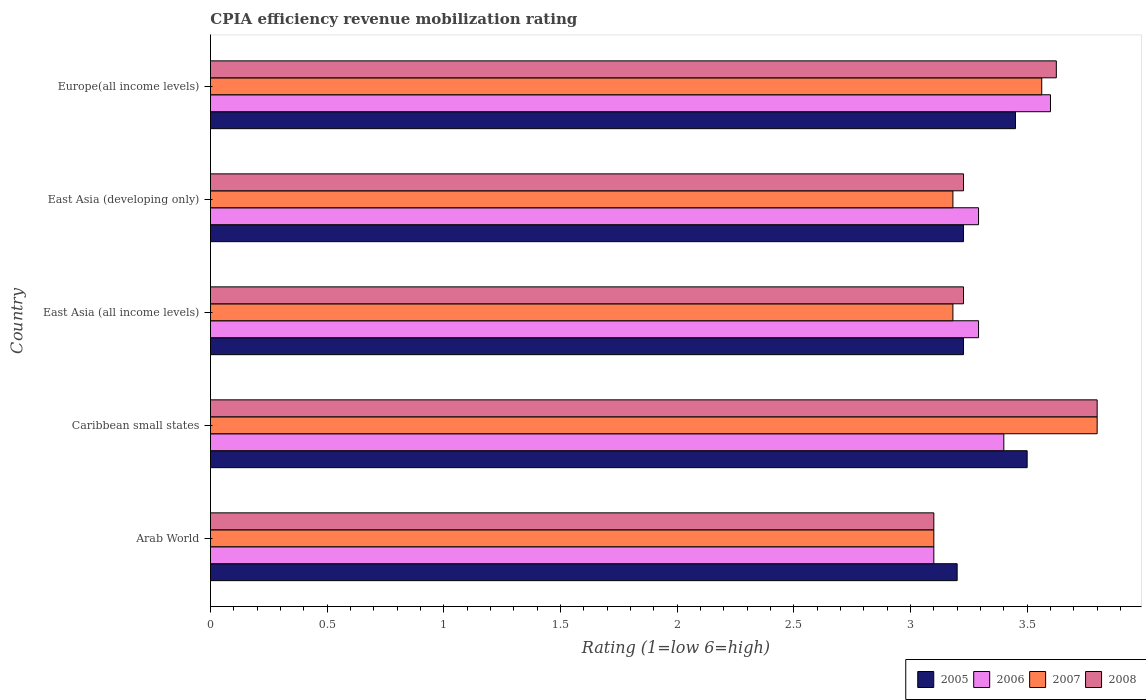How many different coloured bars are there?
Provide a succinct answer. 4. Are the number of bars per tick equal to the number of legend labels?
Offer a very short reply. Yes. Are the number of bars on each tick of the Y-axis equal?
Offer a terse response. Yes. How many bars are there on the 5th tick from the top?
Give a very brief answer. 4. How many bars are there on the 1st tick from the bottom?
Make the answer very short. 4. What is the label of the 5th group of bars from the top?
Provide a short and direct response. Arab World. In how many cases, is the number of bars for a given country not equal to the number of legend labels?
Your answer should be compact. 0. What is the CPIA rating in 2006 in East Asia (all income levels)?
Provide a succinct answer. 3.29. Across all countries, what is the maximum CPIA rating in 2008?
Your answer should be compact. 3.8. Across all countries, what is the minimum CPIA rating in 2008?
Provide a short and direct response. 3.1. In which country was the CPIA rating in 2008 maximum?
Offer a terse response. Caribbean small states. In which country was the CPIA rating in 2008 minimum?
Make the answer very short. Arab World. What is the total CPIA rating in 2007 in the graph?
Make the answer very short. 16.83. What is the difference between the CPIA rating in 2007 in Caribbean small states and the CPIA rating in 2006 in Europe(all income levels)?
Provide a succinct answer. 0.2. What is the average CPIA rating in 2007 per country?
Make the answer very short. 3.37. What is the difference between the CPIA rating in 2006 and CPIA rating in 2005 in Caribbean small states?
Your response must be concise. -0.1. What is the ratio of the CPIA rating in 2005 in Arab World to that in East Asia (all income levels)?
Provide a succinct answer. 0.99. Is the CPIA rating in 2005 in Arab World less than that in East Asia (all income levels)?
Ensure brevity in your answer.  Yes. What is the difference between the highest and the second highest CPIA rating in 2006?
Make the answer very short. 0.2. What is the difference between the highest and the lowest CPIA rating in 2005?
Your answer should be compact. 0.3. In how many countries, is the CPIA rating in 2005 greater than the average CPIA rating in 2005 taken over all countries?
Your answer should be compact. 2. Is the sum of the CPIA rating in 2008 in Caribbean small states and East Asia (developing only) greater than the maximum CPIA rating in 2005 across all countries?
Make the answer very short. Yes. Is it the case that in every country, the sum of the CPIA rating in 2007 and CPIA rating in 2006 is greater than the sum of CPIA rating in 2008 and CPIA rating in 2005?
Ensure brevity in your answer.  No. Is it the case that in every country, the sum of the CPIA rating in 2005 and CPIA rating in 2006 is greater than the CPIA rating in 2007?
Provide a short and direct response. Yes. How many countries are there in the graph?
Your response must be concise. 5. What is the difference between two consecutive major ticks on the X-axis?
Give a very brief answer. 0.5. Are the values on the major ticks of X-axis written in scientific E-notation?
Offer a very short reply. No. Does the graph contain any zero values?
Your answer should be compact. No. Where does the legend appear in the graph?
Your response must be concise. Bottom right. How many legend labels are there?
Keep it short and to the point. 4. How are the legend labels stacked?
Your response must be concise. Horizontal. What is the title of the graph?
Keep it short and to the point. CPIA efficiency revenue mobilization rating. Does "2014" appear as one of the legend labels in the graph?
Your response must be concise. No. What is the label or title of the X-axis?
Your response must be concise. Rating (1=low 6=high). What is the Rating (1=low 6=high) in 2006 in Arab World?
Make the answer very short. 3.1. What is the Rating (1=low 6=high) of 2007 in Arab World?
Offer a terse response. 3.1. What is the Rating (1=low 6=high) of 2008 in Arab World?
Give a very brief answer. 3.1. What is the Rating (1=low 6=high) in 2005 in Caribbean small states?
Provide a short and direct response. 3.5. What is the Rating (1=low 6=high) in 2006 in Caribbean small states?
Give a very brief answer. 3.4. What is the Rating (1=low 6=high) of 2007 in Caribbean small states?
Your response must be concise. 3.8. What is the Rating (1=low 6=high) in 2005 in East Asia (all income levels)?
Make the answer very short. 3.23. What is the Rating (1=low 6=high) in 2006 in East Asia (all income levels)?
Ensure brevity in your answer.  3.29. What is the Rating (1=low 6=high) of 2007 in East Asia (all income levels)?
Your response must be concise. 3.18. What is the Rating (1=low 6=high) of 2008 in East Asia (all income levels)?
Keep it short and to the point. 3.23. What is the Rating (1=low 6=high) of 2005 in East Asia (developing only)?
Provide a short and direct response. 3.23. What is the Rating (1=low 6=high) of 2006 in East Asia (developing only)?
Your answer should be very brief. 3.29. What is the Rating (1=low 6=high) in 2007 in East Asia (developing only)?
Make the answer very short. 3.18. What is the Rating (1=low 6=high) of 2008 in East Asia (developing only)?
Provide a succinct answer. 3.23. What is the Rating (1=low 6=high) of 2005 in Europe(all income levels)?
Offer a terse response. 3.45. What is the Rating (1=low 6=high) in 2006 in Europe(all income levels)?
Ensure brevity in your answer.  3.6. What is the Rating (1=low 6=high) of 2007 in Europe(all income levels)?
Your answer should be very brief. 3.56. What is the Rating (1=low 6=high) in 2008 in Europe(all income levels)?
Provide a succinct answer. 3.62. Across all countries, what is the maximum Rating (1=low 6=high) of 2005?
Give a very brief answer. 3.5. Across all countries, what is the maximum Rating (1=low 6=high) of 2006?
Keep it short and to the point. 3.6. Across all countries, what is the maximum Rating (1=low 6=high) of 2008?
Provide a succinct answer. 3.8. Across all countries, what is the minimum Rating (1=low 6=high) in 2006?
Your answer should be very brief. 3.1. What is the total Rating (1=low 6=high) in 2005 in the graph?
Your answer should be very brief. 16.6. What is the total Rating (1=low 6=high) of 2006 in the graph?
Your answer should be very brief. 16.68. What is the total Rating (1=low 6=high) in 2007 in the graph?
Your answer should be compact. 16.83. What is the total Rating (1=low 6=high) of 2008 in the graph?
Offer a terse response. 16.98. What is the difference between the Rating (1=low 6=high) of 2005 in Arab World and that in Caribbean small states?
Offer a very short reply. -0.3. What is the difference between the Rating (1=low 6=high) of 2006 in Arab World and that in Caribbean small states?
Provide a succinct answer. -0.3. What is the difference between the Rating (1=low 6=high) of 2007 in Arab World and that in Caribbean small states?
Keep it short and to the point. -0.7. What is the difference between the Rating (1=low 6=high) of 2008 in Arab World and that in Caribbean small states?
Give a very brief answer. -0.7. What is the difference between the Rating (1=low 6=high) in 2005 in Arab World and that in East Asia (all income levels)?
Keep it short and to the point. -0.03. What is the difference between the Rating (1=low 6=high) of 2006 in Arab World and that in East Asia (all income levels)?
Offer a very short reply. -0.19. What is the difference between the Rating (1=low 6=high) in 2007 in Arab World and that in East Asia (all income levels)?
Keep it short and to the point. -0.08. What is the difference between the Rating (1=low 6=high) of 2008 in Arab World and that in East Asia (all income levels)?
Keep it short and to the point. -0.13. What is the difference between the Rating (1=low 6=high) in 2005 in Arab World and that in East Asia (developing only)?
Provide a short and direct response. -0.03. What is the difference between the Rating (1=low 6=high) of 2006 in Arab World and that in East Asia (developing only)?
Keep it short and to the point. -0.19. What is the difference between the Rating (1=low 6=high) in 2007 in Arab World and that in East Asia (developing only)?
Provide a short and direct response. -0.08. What is the difference between the Rating (1=low 6=high) in 2008 in Arab World and that in East Asia (developing only)?
Keep it short and to the point. -0.13. What is the difference between the Rating (1=low 6=high) of 2006 in Arab World and that in Europe(all income levels)?
Keep it short and to the point. -0.5. What is the difference between the Rating (1=low 6=high) of 2007 in Arab World and that in Europe(all income levels)?
Your answer should be very brief. -0.46. What is the difference between the Rating (1=low 6=high) of 2008 in Arab World and that in Europe(all income levels)?
Your response must be concise. -0.53. What is the difference between the Rating (1=low 6=high) of 2005 in Caribbean small states and that in East Asia (all income levels)?
Keep it short and to the point. 0.27. What is the difference between the Rating (1=low 6=high) in 2006 in Caribbean small states and that in East Asia (all income levels)?
Give a very brief answer. 0.11. What is the difference between the Rating (1=low 6=high) in 2007 in Caribbean small states and that in East Asia (all income levels)?
Your answer should be very brief. 0.62. What is the difference between the Rating (1=low 6=high) in 2008 in Caribbean small states and that in East Asia (all income levels)?
Offer a very short reply. 0.57. What is the difference between the Rating (1=low 6=high) of 2005 in Caribbean small states and that in East Asia (developing only)?
Keep it short and to the point. 0.27. What is the difference between the Rating (1=low 6=high) in 2006 in Caribbean small states and that in East Asia (developing only)?
Give a very brief answer. 0.11. What is the difference between the Rating (1=low 6=high) in 2007 in Caribbean small states and that in East Asia (developing only)?
Your answer should be compact. 0.62. What is the difference between the Rating (1=low 6=high) in 2008 in Caribbean small states and that in East Asia (developing only)?
Offer a very short reply. 0.57. What is the difference between the Rating (1=low 6=high) in 2005 in Caribbean small states and that in Europe(all income levels)?
Offer a very short reply. 0.05. What is the difference between the Rating (1=low 6=high) of 2007 in Caribbean small states and that in Europe(all income levels)?
Keep it short and to the point. 0.24. What is the difference between the Rating (1=low 6=high) in 2008 in Caribbean small states and that in Europe(all income levels)?
Offer a terse response. 0.17. What is the difference between the Rating (1=low 6=high) in 2005 in East Asia (all income levels) and that in East Asia (developing only)?
Provide a short and direct response. 0. What is the difference between the Rating (1=low 6=high) of 2008 in East Asia (all income levels) and that in East Asia (developing only)?
Your answer should be very brief. 0. What is the difference between the Rating (1=low 6=high) of 2005 in East Asia (all income levels) and that in Europe(all income levels)?
Give a very brief answer. -0.22. What is the difference between the Rating (1=low 6=high) of 2006 in East Asia (all income levels) and that in Europe(all income levels)?
Keep it short and to the point. -0.31. What is the difference between the Rating (1=low 6=high) of 2007 in East Asia (all income levels) and that in Europe(all income levels)?
Give a very brief answer. -0.38. What is the difference between the Rating (1=low 6=high) of 2008 in East Asia (all income levels) and that in Europe(all income levels)?
Make the answer very short. -0.4. What is the difference between the Rating (1=low 6=high) in 2005 in East Asia (developing only) and that in Europe(all income levels)?
Ensure brevity in your answer.  -0.22. What is the difference between the Rating (1=low 6=high) in 2006 in East Asia (developing only) and that in Europe(all income levels)?
Make the answer very short. -0.31. What is the difference between the Rating (1=low 6=high) of 2007 in East Asia (developing only) and that in Europe(all income levels)?
Give a very brief answer. -0.38. What is the difference between the Rating (1=low 6=high) in 2008 in East Asia (developing only) and that in Europe(all income levels)?
Keep it short and to the point. -0.4. What is the difference between the Rating (1=low 6=high) of 2005 in Arab World and the Rating (1=low 6=high) of 2006 in Caribbean small states?
Ensure brevity in your answer.  -0.2. What is the difference between the Rating (1=low 6=high) in 2005 in Arab World and the Rating (1=low 6=high) in 2007 in Caribbean small states?
Make the answer very short. -0.6. What is the difference between the Rating (1=low 6=high) in 2006 in Arab World and the Rating (1=low 6=high) in 2007 in Caribbean small states?
Offer a terse response. -0.7. What is the difference between the Rating (1=low 6=high) in 2007 in Arab World and the Rating (1=low 6=high) in 2008 in Caribbean small states?
Make the answer very short. -0.7. What is the difference between the Rating (1=low 6=high) in 2005 in Arab World and the Rating (1=low 6=high) in 2006 in East Asia (all income levels)?
Your answer should be very brief. -0.09. What is the difference between the Rating (1=low 6=high) of 2005 in Arab World and the Rating (1=low 6=high) of 2007 in East Asia (all income levels)?
Ensure brevity in your answer.  0.02. What is the difference between the Rating (1=low 6=high) of 2005 in Arab World and the Rating (1=low 6=high) of 2008 in East Asia (all income levels)?
Provide a succinct answer. -0.03. What is the difference between the Rating (1=low 6=high) in 2006 in Arab World and the Rating (1=low 6=high) in 2007 in East Asia (all income levels)?
Ensure brevity in your answer.  -0.08. What is the difference between the Rating (1=low 6=high) in 2006 in Arab World and the Rating (1=low 6=high) in 2008 in East Asia (all income levels)?
Keep it short and to the point. -0.13. What is the difference between the Rating (1=low 6=high) in 2007 in Arab World and the Rating (1=low 6=high) in 2008 in East Asia (all income levels)?
Offer a terse response. -0.13. What is the difference between the Rating (1=low 6=high) of 2005 in Arab World and the Rating (1=low 6=high) of 2006 in East Asia (developing only)?
Provide a short and direct response. -0.09. What is the difference between the Rating (1=low 6=high) of 2005 in Arab World and the Rating (1=low 6=high) of 2007 in East Asia (developing only)?
Keep it short and to the point. 0.02. What is the difference between the Rating (1=low 6=high) in 2005 in Arab World and the Rating (1=low 6=high) in 2008 in East Asia (developing only)?
Offer a terse response. -0.03. What is the difference between the Rating (1=low 6=high) in 2006 in Arab World and the Rating (1=low 6=high) in 2007 in East Asia (developing only)?
Provide a succinct answer. -0.08. What is the difference between the Rating (1=low 6=high) in 2006 in Arab World and the Rating (1=low 6=high) in 2008 in East Asia (developing only)?
Offer a very short reply. -0.13. What is the difference between the Rating (1=low 6=high) in 2007 in Arab World and the Rating (1=low 6=high) in 2008 in East Asia (developing only)?
Offer a very short reply. -0.13. What is the difference between the Rating (1=low 6=high) in 2005 in Arab World and the Rating (1=low 6=high) in 2006 in Europe(all income levels)?
Keep it short and to the point. -0.4. What is the difference between the Rating (1=low 6=high) of 2005 in Arab World and the Rating (1=low 6=high) of 2007 in Europe(all income levels)?
Provide a short and direct response. -0.36. What is the difference between the Rating (1=low 6=high) in 2005 in Arab World and the Rating (1=low 6=high) in 2008 in Europe(all income levels)?
Give a very brief answer. -0.42. What is the difference between the Rating (1=low 6=high) of 2006 in Arab World and the Rating (1=low 6=high) of 2007 in Europe(all income levels)?
Offer a very short reply. -0.46. What is the difference between the Rating (1=low 6=high) in 2006 in Arab World and the Rating (1=low 6=high) in 2008 in Europe(all income levels)?
Your answer should be very brief. -0.53. What is the difference between the Rating (1=low 6=high) in 2007 in Arab World and the Rating (1=low 6=high) in 2008 in Europe(all income levels)?
Your answer should be very brief. -0.53. What is the difference between the Rating (1=low 6=high) in 2005 in Caribbean small states and the Rating (1=low 6=high) in 2006 in East Asia (all income levels)?
Provide a succinct answer. 0.21. What is the difference between the Rating (1=low 6=high) of 2005 in Caribbean small states and the Rating (1=low 6=high) of 2007 in East Asia (all income levels)?
Ensure brevity in your answer.  0.32. What is the difference between the Rating (1=low 6=high) in 2005 in Caribbean small states and the Rating (1=low 6=high) in 2008 in East Asia (all income levels)?
Your response must be concise. 0.27. What is the difference between the Rating (1=low 6=high) of 2006 in Caribbean small states and the Rating (1=low 6=high) of 2007 in East Asia (all income levels)?
Keep it short and to the point. 0.22. What is the difference between the Rating (1=low 6=high) in 2006 in Caribbean small states and the Rating (1=low 6=high) in 2008 in East Asia (all income levels)?
Give a very brief answer. 0.17. What is the difference between the Rating (1=low 6=high) in 2007 in Caribbean small states and the Rating (1=low 6=high) in 2008 in East Asia (all income levels)?
Ensure brevity in your answer.  0.57. What is the difference between the Rating (1=low 6=high) of 2005 in Caribbean small states and the Rating (1=low 6=high) of 2006 in East Asia (developing only)?
Offer a terse response. 0.21. What is the difference between the Rating (1=low 6=high) of 2005 in Caribbean small states and the Rating (1=low 6=high) of 2007 in East Asia (developing only)?
Offer a very short reply. 0.32. What is the difference between the Rating (1=low 6=high) of 2005 in Caribbean small states and the Rating (1=low 6=high) of 2008 in East Asia (developing only)?
Offer a terse response. 0.27. What is the difference between the Rating (1=low 6=high) of 2006 in Caribbean small states and the Rating (1=low 6=high) of 2007 in East Asia (developing only)?
Your answer should be compact. 0.22. What is the difference between the Rating (1=low 6=high) of 2006 in Caribbean small states and the Rating (1=low 6=high) of 2008 in East Asia (developing only)?
Make the answer very short. 0.17. What is the difference between the Rating (1=low 6=high) in 2007 in Caribbean small states and the Rating (1=low 6=high) in 2008 in East Asia (developing only)?
Make the answer very short. 0.57. What is the difference between the Rating (1=low 6=high) of 2005 in Caribbean small states and the Rating (1=low 6=high) of 2007 in Europe(all income levels)?
Provide a succinct answer. -0.06. What is the difference between the Rating (1=low 6=high) in 2005 in Caribbean small states and the Rating (1=low 6=high) in 2008 in Europe(all income levels)?
Ensure brevity in your answer.  -0.12. What is the difference between the Rating (1=low 6=high) in 2006 in Caribbean small states and the Rating (1=low 6=high) in 2007 in Europe(all income levels)?
Offer a very short reply. -0.16. What is the difference between the Rating (1=low 6=high) of 2006 in Caribbean small states and the Rating (1=low 6=high) of 2008 in Europe(all income levels)?
Make the answer very short. -0.23. What is the difference between the Rating (1=low 6=high) in 2007 in Caribbean small states and the Rating (1=low 6=high) in 2008 in Europe(all income levels)?
Make the answer very short. 0.17. What is the difference between the Rating (1=low 6=high) of 2005 in East Asia (all income levels) and the Rating (1=low 6=high) of 2006 in East Asia (developing only)?
Make the answer very short. -0.06. What is the difference between the Rating (1=low 6=high) of 2005 in East Asia (all income levels) and the Rating (1=low 6=high) of 2007 in East Asia (developing only)?
Your response must be concise. 0.05. What is the difference between the Rating (1=low 6=high) in 2006 in East Asia (all income levels) and the Rating (1=low 6=high) in 2007 in East Asia (developing only)?
Your response must be concise. 0.11. What is the difference between the Rating (1=low 6=high) in 2006 in East Asia (all income levels) and the Rating (1=low 6=high) in 2008 in East Asia (developing only)?
Ensure brevity in your answer.  0.06. What is the difference between the Rating (1=low 6=high) in 2007 in East Asia (all income levels) and the Rating (1=low 6=high) in 2008 in East Asia (developing only)?
Give a very brief answer. -0.05. What is the difference between the Rating (1=low 6=high) of 2005 in East Asia (all income levels) and the Rating (1=low 6=high) of 2006 in Europe(all income levels)?
Offer a terse response. -0.37. What is the difference between the Rating (1=low 6=high) of 2005 in East Asia (all income levels) and the Rating (1=low 6=high) of 2007 in Europe(all income levels)?
Give a very brief answer. -0.34. What is the difference between the Rating (1=low 6=high) in 2005 in East Asia (all income levels) and the Rating (1=low 6=high) in 2008 in Europe(all income levels)?
Provide a succinct answer. -0.4. What is the difference between the Rating (1=low 6=high) in 2006 in East Asia (all income levels) and the Rating (1=low 6=high) in 2007 in Europe(all income levels)?
Make the answer very short. -0.27. What is the difference between the Rating (1=low 6=high) in 2006 in East Asia (all income levels) and the Rating (1=low 6=high) in 2008 in Europe(all income levels)?
Offer a very short reply. -0.33. What is the difference between the Rating (1=low 6=high) of 2007 in East Asia (all income levels) and the Rating (1=low 6=high) of 2008 in Europe(all income levels)?
Your answer should be compact. -0.44. What is the difference between the Rating (1=low 6=high) of 2005 in East Asia (developing only) and the Rating (1=low 6=high) of 2006 in Europe(all income levels)?
Give a very brief answer. -0.37. What is the difference between the Rating (1=low 6=high) in 2005 in East Asia (developing only) and the Rating (1=low 6=high) in 2007 in Europe(all income levels)?
Your response must be concise. -0.34. What is the difference between the Rating (1=low 6=high) in 2005 in East Asia (developing only) and the Rating (1=low 6=high) in 2008 in Europe(all income levels)?
Your response must be concise. -0.4. What is the difference between the Rating (1=low 6=high) of 2006 in East Asia (developing only) and the Rating (1=low 6=high) of 2007 in Europe(all income levels)?
Your response must be concise. -0.27. What is the difference between the Rating (1=low 6=high) of 2006 in East Asia (developing only) and the Rating (1=low 6=high) of 2008 in Europe(all income levels)?
Ensure brevity in your answer.  -0.33. What is the difference between the Rating (1=low 6=high) of 2007 in East Asia (developing only) and the Rating (1=low 6=high) of 2008 in Europe(all income levels)?
Keep it short and to the point. -0.44. What is the average Rating (1=low 6=high) of 2005 per country?
Your response must be concise. 3.32. What is the average Rating (1=low 6=high) of 2006 per country?
Make the answer very short. 3.34. What is the average Rating (1=low 6=high) in 2007 per country?
Provide a short and direct response. 3.37. What is the average Rating (1=low 6=high) of 2008 per country?
Keep it short and to the point. 3.4. What is the difference between the Rating (1=low 6=high) of 2005 and Rating (1=low 6=high) of 2006 in Arab World?
Your answer should be very brief. 0.1. What is the difference between the Rating (1=low 6=high) in 2006 and Rating (1=low 6=high) in 2007 in Arab World?
Provide a succinct answer. 0. What is the difference between the Rating (1=low 6=high) in 2006 and Rating (1=low 6=high) in 2008 in Arab World?
Keep it short and to the point. 0. What is the difference between the Rating (1=low 6=high) in 2005 and Rating (1=low 6=high) in 2006 in Caribbean small states?
Give a very brief answer. 0.1. What is the difference between the Rating (1=low 6=high) in 2005 and Rating (1=low 6=high) in 2007 in Caribbean small states?
Provide a succinct answer. -0.3. What is the difference between the Rating (1=low 6=high) in 2006 and Rating (1=low 6=high) in 2007 in Caribbean small states?
Keep it short and to the point. -0.4. What is the difference between the Rating (1=low 6=high) in 2005 and Rating (1=low 6=high) in 2006 in East Asia (all income levels)?
Offer a very short reply. -0.06. What is the difference between the Rating (1=low 6=high) of 2005 and Rating (1=low 6=high) of 2007 in East Asia (all income levels)?
Make the answer very short. 0.05. What is the difference between the Rating (1=low 6=high) in 2005 and Rating (1=low 6=high) in 2008 in East Asia (all income levels)?
Your answer should be very brief. 0. What is the difference between the Rating (1=low 6=high) in 2006 and Rating (1=low 6=high) in 2007 in East Asia (all income levels)?
Your answer should be compact. 0.11. What is the difference between the Rating (1=low 6=high) in 2006 and Rating (1=low 6=high) in 2008 in East Asia (all income levels)?
Your answer should be very brief. 0.06. What is the difference between the Rating (1=low 6=high) of 2007 and Rating (1=low 6=high) of 2008 in East Asia (all income levels)?
Make the answer very short. -0.05. What is the difference between the Rating (1=low 6=high) of 2005 and Rating (1=low 6=high) of 2006 in East Asia (developing only)?
Keep it short and to the point. -0.06. What is the difference between the Rating (1=low 6=high) of 2005 and Rating (1=low 6=high) of 2007 in East Asia (developing only)?
Keep it short and to the point. 0.05. What is the difference between the Rating (1=low 6=high) of 2006 and Rating (1=low 6=high) of 2007 in East Asia (developing only)?
Provide a succinct answer. 0.11. What is the difference between the Rating (1=low 6=high) in 2006 and Rating (1=low 6=high) in 2008 in East Asia (developing only)?
Your answer should be very brief. 0.06. What is the difference between the Rating (1=low 6=high) in 2007 and Rating (1=low 6=high) in 2008 in East Asia (developing only)?
Offer a very short reply. -0.05. What is the difference between the Rating (1=low 6=high) of 2005 and Rating (1=low 6=high) of 2007 in Europe(all income levels)?
Your response must be concise. -0.11. What is the difference between the Rating (1=low 6=high) in 2005 and Rating (1=low 6=high) in 2008 in Europe(all income levels)?
Give a very brief answer. -0.17. What is the difference between the Rating (1=low 6=high) in 2006 and Rating (1=low 6=high) in 2007 in Europe(all income levels)?
Make the answer very short. 0.04. What is the difference between the Rating (1=low 6=high) in 2006 and Rating (1=low 6=high) in 2008 in Europe(all income levels)?
Provide a succinct answer. -0.03. What is the difference between the Rating (1=low 6=high) of 2007 and Rating (1=low 6=high) of 2008 in Europe(all income levels)?
Offer a very short reply. -0.06. What is the ratio of the Rating (1=low 6=high) in 2005 in Arab World to that in Caribbean small states?
Keep it short and to the point. 0.91. What is the ratio of the Rating (1=low 6=high) of 2006 in Arab World to that in Caribbean small states?
Your response must be concise. 0.91. What is the ratio of the Rating (1=low 6=high) of 2007 in Arab World to that in Caribbean small states?
Your answer should be compact. 0.82. What is the ratio of the Rating (1=low 6=high) of 2008 in Arab World to that in Caribbean small states?
Provide a succinct answer. 0.82. What is the ratio of the Rating (1=low 6=high) in 2005 in Arab World to that in East Asia (all income levels)?
Make the answer very short. 0.99. What is the ratio of the Rating (1=low 6=high) of 2006 in Arab World to that in East Asia (all income levels)?
Keep it short and to the point. 0.94. What is the ratio of the Rating (1=low 6=high) in 2007 in Arab World to that in East Asia (all income levels)?
Provide a succinct answer. 0.97. What is the ratio of the Rating (1=low 6=high) in 2008 in Arab World to that in East Asia (all income levels)?
Your response must be concise. 0.96. What is the ratio of the Rating (1=low 6=high) of 2006 in Arab World to that in East Asia (developing only)?
Make the answer very short. 0.94. What is the ratio of the Rating (1=low 6=high) of 2007 in Arab World to that in East Asia (developing only)?
Ensure brevity in your answer.  0.97. What is the ratio of the Rating (1=low 6=high) in 2008 in Arab World to that in East Asia (developing only)?
Your response must be concise. 0.96. What is the ratio of the Rating (1=low 6=high) in 2005 in Arab World to that in Europe(all income levels)?
Provide a succinct answer. 0.93. What is the ratio of the Rating (1=low 6=high) of 2006 in Arab World to that in Europe(all income levels)?
Offer a very short reply. 0.86. What is the ratio of the Rating (1=low 6=high) of 2007 in Arab World to that in Europe(all income levels)?
Your answer should be compact. 0.87. What is the ratio of the Rating (1=low 6=high) of 2008 in Arab World to that in Europe(all income levels)?
Provide a succinct answer. 0.86. What is the ratio of the Rating (1=low 6=high) in 2005 in Caribbean small states to that in East Asia (all income levels)?
Your response must be concise. 1.08. What is the ratio of the Rating (1=low 6=high) of 2006 in Caribbean small states to that in East Asia (all income levels)?
Provide a short and direct response. 1.03. What is the ratio of the Rating (1=low 6=high) of 2007 in Caribbean small states to that in East Asia (all income levels)?
Make the answer very short. 1.19. What is the ratio of the Rating (1=low 6=high) in 2008 in Caribbean small states to that in East Asia (all income levels)?
Make the answer very short. 1.18. What is the ratio of the Rating (1=low 6=high) of 2005 in Caribbean small states to that in East Asia (developing only)?
Provide a succinct answer. 1.08. What is the ratio of the Rating (1=low 6=high) in 2006 in Caribbean small states to that in East Asia (developing only)?
Offer a very short reply. 1.03. What is the ratio of the Rating (1=low 6=high) of 2007 in Caribbean small states to that in East Asia (developing only)?
Keep it short and to the point. 1.19. What is the ratio of the Rating (1=low 6=high) of 2008 in Caribbean small states to that in East Asia (developing only)?
Offer a very short reply. 1.18. What is the ratio of the Rating (1=low 6=high) of 2005 in Caribbean small states to that in Europe(all income levels)?
Provide a succinct answer. 1.01. What is the ratio of the Rating (1=low 6=high) of 2007 in Caribbean small states to that in Europe(all income levels)?
Your answer should be very brief. 1.07. What is the ratio of the Rating (1=low 6=high) of 2008 in Caribbean small states to that in Europe(all income levels)?
Give a very brief answer. 1.05. What is the ratio of the Rating (1=low 6=high) of 2006 in East Asia (all income levels) to that in East Asia (developing only)?
Give a very brief answer. 1. What is the ratio of the Rating (1=low 6=high) in 2008 in East Asia (all income levels) to that in East Asia (developing only)?
Provide a short and direct response. 1. What is the ratio of the Rating (1=low 6=high) of 2005 in East Asia (all income levels) to that in Europe(all income levels)?
Offer a terse response. 0.94. What is the ratio of the Rating (1=low 6=high) of 2006 in East Asia (all income levels) to that in Europe(all income levels)?
Offer a very short reply. 0.91. What is the ratio of the Rating (1=low 6=high) of 2007 in East Asia (all income levels) to that in Europe(all income levels)?
Give a very brief answer. 0.89. What is the ratio of the Rating (1=low 6=high) of 2008 in East Asia (all income levels) to that in Europe(all income levels)?
Your response must be concise. 0.89. What is the ratio of the Rating (1=low 6=high) in 2005 in East Asia (developing only) to that in Europe(all income levels)?
Provide a succinct answer. 0.94. What is the ratio of the Rating (1=low 6=high) in 2006 in East Asia (developing only) to that in Europe(all income levels)?
Your answer should be very brief. 0.91. What is the ratio of the Rating (1=low 6=high) of 2007 in East Asia (developing only) to that in Europe(all income levels)?
Offer a terse response. 0.89. What is the ratio of the Rating (1=low 6=high) of 2008 in East Asia (developing only) to that in Europe(all income levels)?
Offer a terse response. 0.89. What is the difference between the highest and the second highest Rating (1=low 6=high) of 2005?
Provide a short and direct response. 0.05. What is the difference between the highest and the second highest Rating (1=low 6=high) in 2007?
Make the answer very short. 0.24. What is the difference between the highest and the second highest Rating (1=low 6=high) in 2008?
Make the answer very short. 0.17. What is the difference between the highest and the lowest Rating (1=low 6=high) of 2007?
Provide a short and direct response. 0.7. 